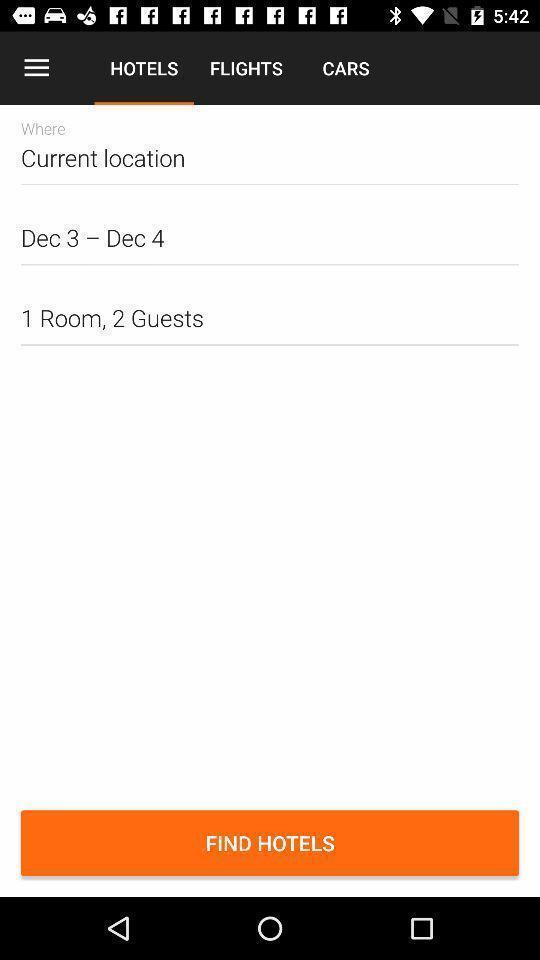What details can you identify in this image? Search page for searching hotels. 